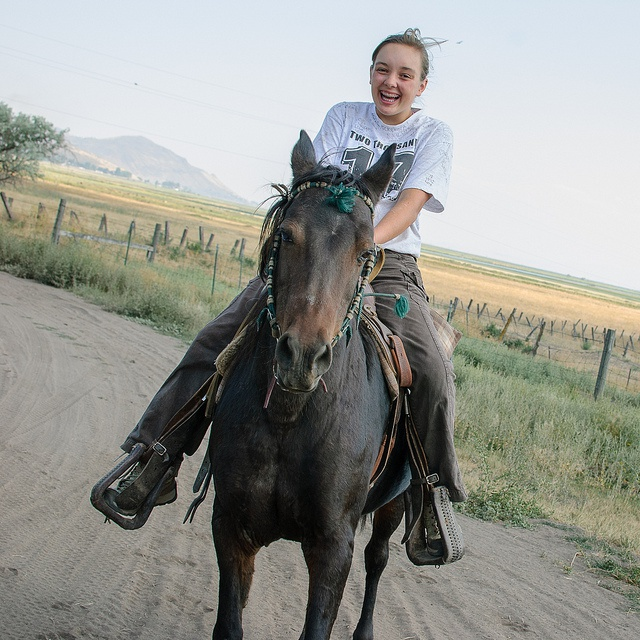Describe the objects in this image and their specific colors. I can see horse in lightgray, black, gray, and darkgray tones and people in lightgray, black, gray, lavender, and darkgray tones in this image. 